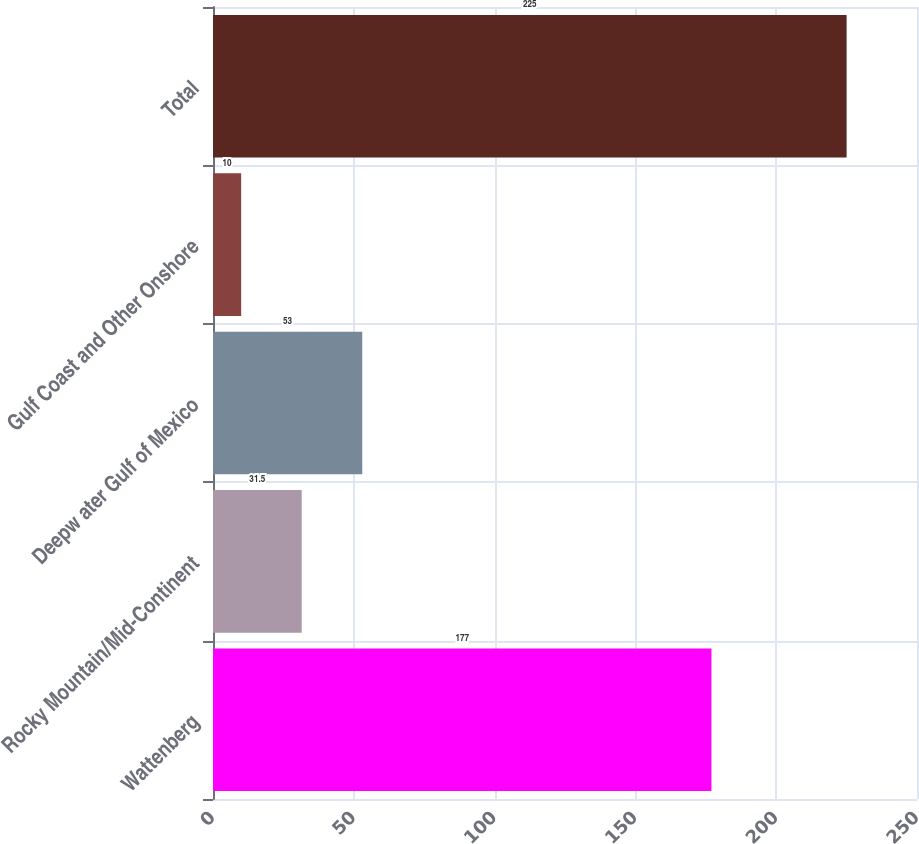<chart> <loc_0><loc_0><loc_500><loc_500><bar_chart><fcel>Wattenberg<fcel>Rocky Mountain/Mid-Continent<fcel>Deepw ater Gulf of Mexico<fcel>Gulf Coast and Other Onshore<fcel>Total<nl><fcel>177<fcel>31.5<fcel>53<fcel>10<fcel>225<nl></chart> 